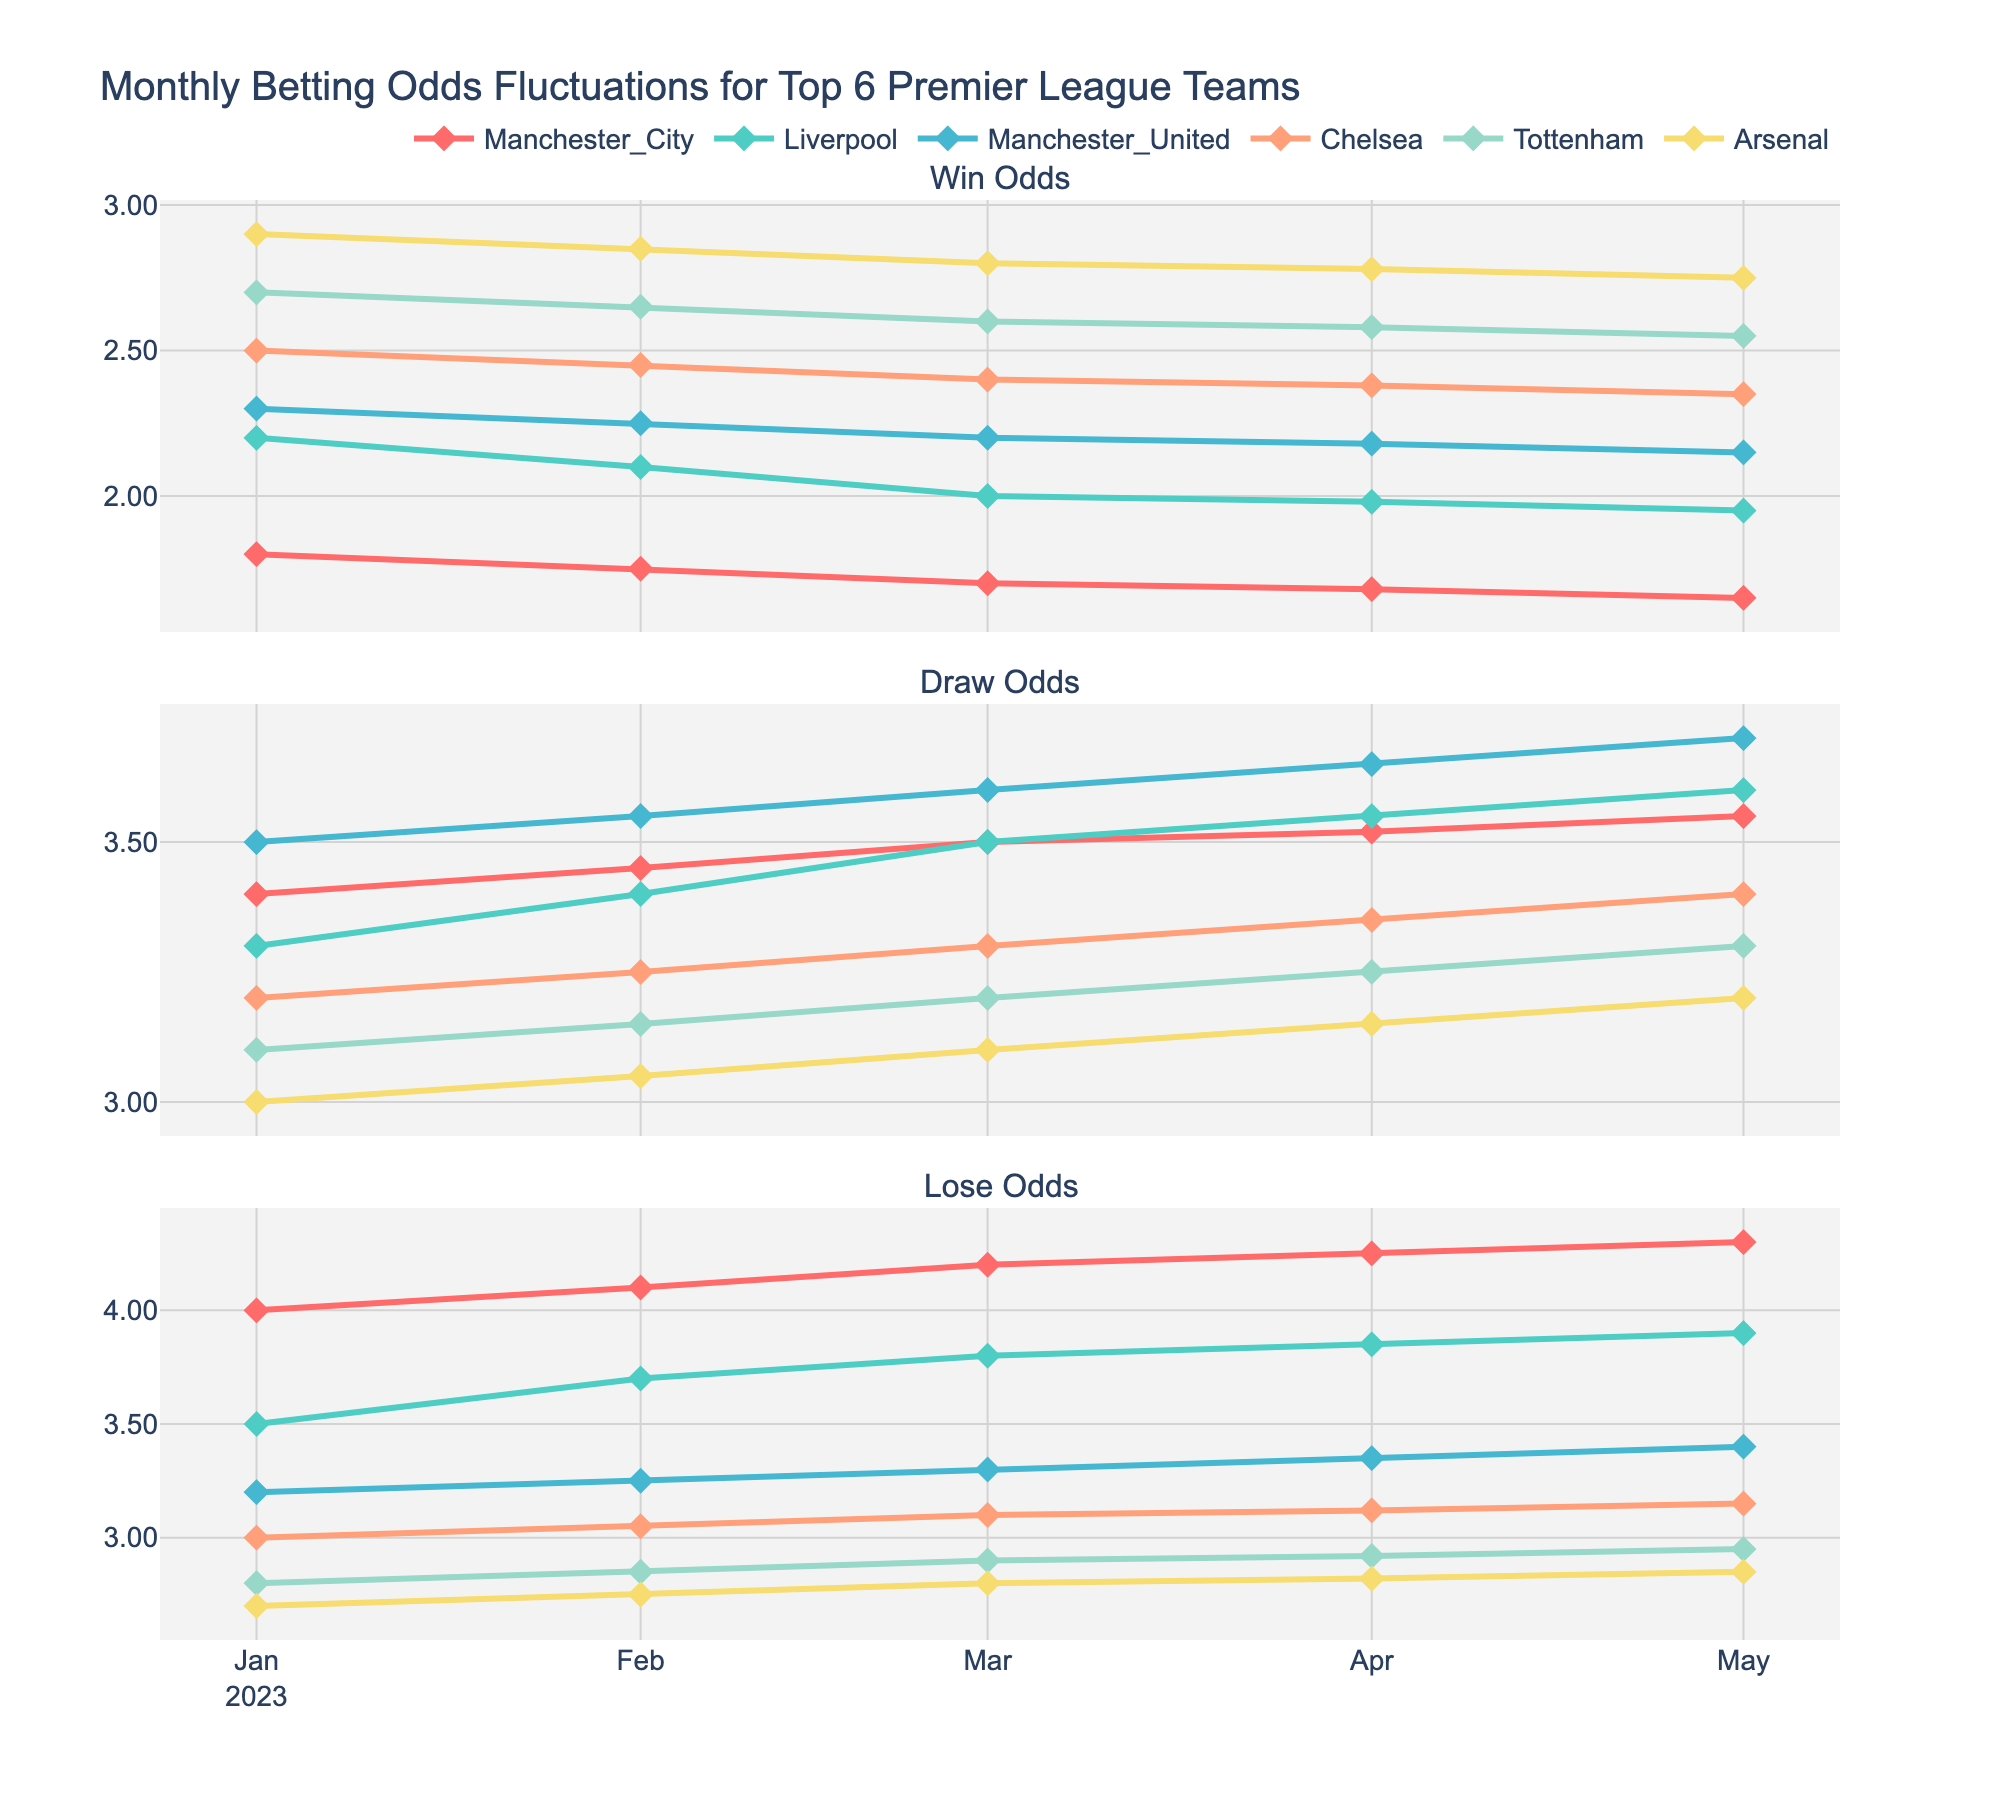What's the title of the figure? The title of the figure is found at the top and gives an overview of what the plot represents. Here it states: "Monthly Betting Odds Fluctuations for Top 6 Premier League Teams".
Answer: Monthly Betting Odds Fluctuations for Top 6 Premier League Teams How many teams' odds are tracked in the figure? The legend in the plot shows the names and colors representing different teams. There are six teams listed: Manchester City, Liverpool, Manchester United, Chelsea, Tottenham, and Arsenal.
Answer: 6 Which team consistently has the lowest Win Odds across the months? By examining the 'Win Odds' subplot and comparing the lines for each team, Manchester City consistently has the lowest Win Odds throughout the months.
Answer: Manchester City How do Liverpool's Draw Odds change from January to May? By following the trend line of Liverpool's Draw Odds from January to May in the subplot, it increases slightly from 3.30 in January to 3.60 in May.
Answer: Increase from 3.30 to 3.60 Which month shows the highest Lose Odds for Arsenal? By looking at the 'Lose Odds' subplot for Arsenal across the months, the highest value is in May, where it reaches 2.85.
Answer: May What is the difference between Win Odds of Manchester City and Arsenal in April? To find this, take the Win Odds of Manchester City (1.68) and Arsenal (2.78) in April and compute the difference, which is 2.78 - 1.68.
Answer: 1.10 During which months is Manchester United's Win Odds less than 2.20? Check the 'Win Odds' subplot for Manchester United, and observe that it is below 2.20 in March (2.20) and April (2.18).
Answer: March and April Compare the trend of Win Odds for Tottenham and Chelsea from January to May. Look at the trend lines in the 'Win Odds' subplot for Tottenham and Chelsea. Both decline over time, but Tottenham starts higher and declines slightly steeper compared to Chelsea.
Answer: Both decline, Tottenham's decline is steeper Which team had a constant Win Odds value for three consecutive months? By checking each team's 'Win Odds' trend lines, Arsenal has a constant value from March to May (2.80).
Answer: Arsenal What is the average Lose Odds for Manchester City across all months? Sum the Lose Odds of Manchester City for all months (4.00, 4.10, 4.20, 4.25, 4.30) and divide by the number of months (5): (4.00 + 4.10 + 4.20 + 4.25 + 4.30)/5.
Answer: 4.17 